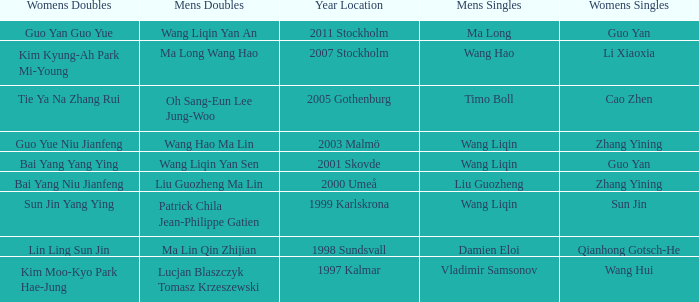What is the place and when was the year when the women's doubles womens were Bai yang Niu Jianfeng? 2000 Umeå. 